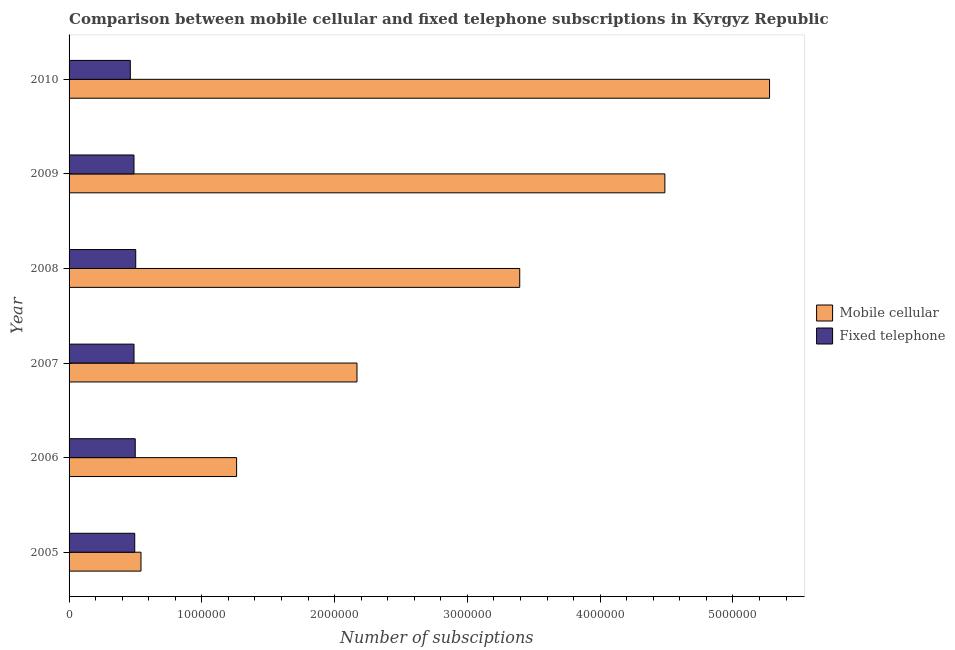How many different coloured bars are there?
Ensure brevity in your answer.  2. Are the number of bars per tick equal to the number of legend labels?
Make the answer very short. Yes. How many bars are there on the 4th tick from the bottom?
Provide a succinct answer. 2. What is the label of the 2nd group of bars from the top?
Give a very brief answer. 2009. In how many cases, is the number of bars for a given year not equal to the number of legend labels?
Keep it short and to the point. 0. What is the number of mobile cellular subscriptions in 2009?
Give a very brief answer. 4.49e+06. Across all years, what is the maximum number of fixed telephone subscriptions?
Make the answer very short. 5.02e+05. Across all years, what is the minimum number of fixed telephone subscriptions?
Offer a very short reply. 4.61e+05. What is the total number of mobile cellular subscriptions in the graph?
Your response must be concise. 1.71e+07. What is the difference between the number of mobile cellular subscriptions in 2007 and that in 2010?
Your answer should be compact. -3.11e+06. What is the difference between the number of mobile cellular subscriptions in 2009 and the number of fixed telephone subscriptions in 2010?
Provide a succinct answer. 4.03e+06. What is the average number of mobile cellular subscriptions per year?
Your answer should be very brief. 2.85e+06. In the year 2005, what is the difference between the number of mobile cellular subscriptions and number of fixed telephone subscriptions?
Provide a succinct answer. 4.71e+04. What is the ratio of the number of mobile cellular subscriptions in 2006 to that in 2009?
Provide a short and direct response. 0.28. What is the difference between the highest and the second highest number of mobile cellular subscriptions?
Provide a succinct answer. 7.88e+05. What is the difference between the highest and the lowest number of mobile cellular subscriptions?
Provide a succinct answer. 4.73e+06. In how many years, is the number of fixed telephone subscriptions greater than the average number of fixed telephone subscriptions taken over all years?
Keep it short and to the point. 4. Is the sum of the number of mobile cellular subscriptions in 2005 and 2010 greater than the maximum number of fixed telephone subscriptions across all years?
Ensure brevity in your answer.  Yes. What does the 1st bar from the top in 2010 represents?
Make the answer very short. Fixed telephone. What does the 2nd bar from the bottom in 2005 represents?
Your answer should be compact. Fixed telephone. How many years are there in the graph?
Offer a terse response. 6. What is the difference between two consecutive major ticks on the X-axis?
Your response must be concise. 1.00e+06. Does the graph contain grids?
Ensure brevity in your answer.  No. How many legend labels are there?
Ensure brevity in your answer.  2. What is the title of the graph?
Your response must be concise. Comparison between mobile cellular and fixed telephone subscriptions in Kyrgyz Republic. Does "Netherlands" appear as one of the legend labels in the graph?
Your response must be concise. No. What is the label or title of the X-axis?
Make the answer very short. Number of subsciptions. What is the label or title of the Y-axis?
Your answer should be very brief. Year. What is the Number of subsciptions of Mobile cellular in 2005?
Offer a terse response. 5.42e+05. What is the Number of subsciptions of Fixed telephone in 2005?
Your answer should be very brief. 4.95e+05. What is the Number of subsciptions in Mobile cellular in 2006?
Your answer should be very brief. 1.26e+06. What is the Number of subsciptions in Fixed telephone in 2006?
Give a very brief answer. 4.98e+05. What is the Number of subsciptions of Mobile cellular in 2007?
Offer a very short reply. 2.17e+06. What is the Number of subsciptions of Fixed telephone in 2007?
Your answer should be very brief. 4.89e+05. What is the Number of subsciptions in Mobile cellular in 2008?
Your answer should be compact. 3.39e+06. What is the Number of subsciptions in Fixed telephone in 2008?
Make the answer very short. 5.02e+05. What is the Number of subsciptions in Mobile cellular in 2009?
Provide a short and direct response. 4.49e+06. What is the Number of subsciptions in Fixed telephone in 2009?
Your answer should be compact. 4.89e+05. What is the Number of subsciptions of Mobile cellular in 2010?
Your response must be concise. 5.28e+06. What is the Number of subsciptions of Fixed telephone in 2010?
Offer a terse response. 4.61e+05. Across all years, what is the maximum Number of subsciptions of Mobile cellular?
Provide a succinct answer. 5.28e+06. Across all years, what is the maximum Number of subsciptions of Fixed telephone?
Give a very brief answer. 5.02e+05. Across all years, what is the minimum Number of subsciptions in Mobile cellular?
Your answer should be very brief. 5.42e+05. Across all years, what is the minimum Number of subsciptions in Fixed telephone?
Offer a very short reply. 4.61e+05. What is the total Number of subsciptions in Mobile cellular in the graph?
Provide a succinct answer. 1.71e+07. What is the total Number of subsciptions of Fixed telephone in the graph?
Give a very brief answer. 2.93e+06. What is the difference between the Number of subsciptions in Mobile cellular in 2005 and that in 2006?
Your answer should be very brief. -7.20e+05. What is the difference between the Number of subsciptions of Fixed telephone in 2005 and that in 2006?
Ensure brevity in your answer.  -3825. What is the difference between the Number of subsciptions of Mobile cellular in 2005 and that in 2007?
Keep it short and to the point. -1.63e+06. What is the difference between the Number of subsciptions of Fixed telephone in 2005 and that in 2007?
Offer a very short reply. 5451. What is the difference between the Number of subsciptions in Mobile cellular in 2005 and that in 2008?
Make the answer very short. -2.85e+06. What is the difference between the Number of subsciptions of Fixed telephone in 2005 and that in 2008?
Keep it short and to the point. -7517. What is the difference between the Number of subsciptions of Mobile cellular in 2005 and that in 2009?
Ensure brevity in your answer.  -3.95e+06. What is the difference between the Number of subsciptions in Fixed telephone in 2005 and that in 2009?
Keep it short and to the point. 5650. What is the difference between the Number of subsciptions of Mobile cellular in 2005 and that in 2010?
Provide a short and direct response. -4.73e+06. What is the difference between the Number of subsciptions in Fixed telephone in 2005 and that in 2010?
Your answer should be very brief. 3.32e+04. What is the difference between the Number of subsciptions in Mobile cellular in 2006 and that in 2007?
Give a very brief answer. -9.07e+05. What is the difference between the Number of subsciptions in Fixed telephone in 2006 and that in 2007?
Provide a short and direct response. 9276. What is the difference between the Number of subsciptions of Mobile cellular in 2006 and that in 2008?
Give a very brief answer. -2.13e+06. What is the difference between the Number of subsciptions of Fixed telephone in 2006 and that in 2008?
Your answer should be compact. -3692. What is the difference between the Number of subsciptions of Mobile cellular in 2006 and that in 2009?
Keep it short and to the point. -3.23e+06. What is the difference between the Number of subsciptions in Fixed telephone in 2006 and that in 2009?
Keep it short and to the point. 9475. What is the difference between the Number of subsciptions in Mobile cellular in 2006 and that in 2010?
Provide a succinct answer. -4.01e+06. What is the difference between the Number of subsciptions in Fixed telephone in 2006 and that in 2010?
Ensure brevity in your answer.  3.71e+04. What is the difference between the Number of subsciptions of Mobile cellular in 2007 and that in 2008?
Give a very brief answer. -1.23e+06. What is the difference between the Number of subsciptions of Fixed telephone in 2007 and that in 2008?
Your answer should be very brief. -1.30e+04. What is the difference between the Number of subsciptions in Mobile cellular in 2007 and that in 2009?
Give a very brief answer. -2.32e+06. What is the difference between the Number of subsciptions of Fixed telephone in 2007 and that in 2009?
Provide a short and direct response. 199. What is the difference between the Number of subsciptions in Mobile cellular in 2007 and that in 2010?
Keep it short and to the point. -3.11e+06. What is the difference between the Number of subsciptions of Fixed telephone in 2007 and that in 2010?
Offer a very short reply. 2.78e+04. What is the difference between the Number of subsciptions in Mobile cellular in 2008 and that in 2009?
Your response must be concise. -1.09e+06. What is the difference between the Number of subsciptions of Fixed telephone in 2008 and that in 2009?
Offer a terse response. 1.32e+04. What is the difference between the Number of subsciptions of Mobile cellular in 2008 and that in 2010?
Your response must be concise. -1.88e+06. What is the difference between the Number of subsciptions in Fixed telephone in 2008 and that in 2010?
Offer a terse response. 4.07e+04. What is the difference between the Number of subsciptions of Mobile cellular in 2009 and that in 2010?
Make the answer very short. -7.88e+05. What is the difference between the Number of subsciptions of Fixed telephone in 2009 and that in 2010?
Your answer should be very brief. 2.76e+04. What is the difference between the Number of subsciptions of Mobile cellular in 2005 and the Number of subsciptions of Fixed telephone in 2006?
Your answer should be compact. 4.33e+04. What is the difference between the Number of subsciptions of Mobile cellular in 2005 and the Number of subsciptions of Fixed telephone in 2007?
Give a very brief answer. 5.26e+04. What is the difference between the Number of subsciptions of Mobile cellular in 2005 and the Number of subsciptions of Fixed telephone in 2008?
Offer a very short reply. 3.96e+04. What is the difference between the Number of subsciptions of Mobile cellular in 2005 and the Number of subsciptions of Fixed telephone in 2009?
Your answer should be very brief. 5.28e+04. What is the difference between the Number of subsciptions of Mobile cellular in 2005 and the Number of subsciptions of Fixed telephone in 2010?
Provide a succinct answer. 8.04e+04. What is the difference between the Number of subsciptions in Mobile cellular in 2006 and the Number of subsciptions in Fixed telephone in 2007?
Your response must be concise. 7.73e+05. What is the difference between the Number of subsciptions of Mobile cellular in 2006 and the Number of subsciptions of Fixed telephone in 2008?
Your response must be concise. 7.60e+05. What is the difference between the Number of subsciptions in Mobile cellular in 2006 and the Number of subsciptions in Fixed telephone in 2009?
Keep it short and to the point. 7.73e+05. What is the difference between the Number of subsciptions of Mobile cellular in 2006 and the Number of subsciptions of Fixed telephone in 2010?
Offer a terse response. 8.00e+05. What is the difference between the Number of subsciptions of Mobile cellular in 2007 and the Number of subsciptions of Fixed telephone in 2008?
Keep it short and to the point. 1.67e+06. What is the difference between the Number of subsciptions in Mobile cellular in 2007 and the Number of subsciptions in Fixed telephone in 2009?
Offer a terse response. 1.68e+06. What is the difference between the Number of subsciptions in Mobile cellular in 2007 and the Number of subsciptions in Fixed telephone in 2010?
Offer a very short reply. 1.71e+06. What is the difference between the Number of subsciptions of Mobile cellular in 2008 and the Number of subsciptions of Fixed telephone in 2009?
Make the answer very short. 2.91e+06. What is the difference between the Number of subsciptions of Mobile cellular in 2008 and the Number of subsciptions of Fixed telephone in 2010?
Ensure brevity in your answer.  2.93e+06. What is the difference between the Number of subsciptions in Mobile cellular in 2009 and the Number of subsciptions in Fixed telephone in 2010?
Ensure brevity in your answer.  4.03e+06. What is the average Number of subsciptions of Mobile cellular per year?
Provide a succinct answer. 2.85e+06. What is the average Number of subsciptions in Fixed telephone per year?
Ensure brevity in your answer.  4.89e+05. In the year 2005, what is the difference between the Number of subsciptions in Mobile cellular and Number of subsciptions in Fixed telephone?
Your answer should be compact. 4.71e+04. In the year 2006, what is the difference between the Number of subsciptions in Mobile cellular and Number of subsciptions in Fixed telephone?
Provide a short and direct response. 7.63e+05. In the year 2007, what is the difference between the Number of subsciptions in Mobile cellular and Number of subsciptions in Fixed telephone?
Your answer should be compact. 1.68e+06. In the year 2008, what is the difference between the Number of subsciptions of Mobile cellular and Number of subsciptions of Fixed telephone?
Offer a very short reply. 2.89e+06. In the year 2009, what is the difference between the Number of subsciptions in Mobile cellular and Number of subsciptions in Fixed telephone?
Your response must be concise. 4.00e+06. In the year 2010, what is the difference between the Number of subsciptions of Mobile cellular and Number of subsciptions of Fixed telephone?
Your answer should be very brief. 4.81e+06. What is the ratio of the Number of subsciptions in Mobile cellular in 2005 to that in 2006?
Your answer should be compact. 0.43. What is the ratio of the Number of subsciptions of Fixed telephone in 2005 to that in 2006?
Provide a short and direct response. 0.99. What is the ratio of the Number of subsciptions of Mobile cellular in 2005 to that in 2007?
Your answer should be very brief. 0.25. What is the ratio of the Number of subsciptions of Fixed telephone in 2005 to that in 2007?
Your response must be concise. 1.01. What is the ratio of the Number of subsciptions in Mobile cellular in 2005 to that in 2008?
Provide a short and direct response. 0.16. What is the ratio of the Number of subsciptions of Fixed telephone in 2005 to that in 2008?
Provide a succinct answer. 0.98. What is the ratio of the Number of subsciptions of Mobile cellular in 2005 to that in 2009?
Provide a short and direct response. 0.12. What is the ratio of the Number of subsciptions of Fixed telephone in 2005 to that in 2009?
Ensure brevity in your answer.  1.01. What is the ratio of the Number of subsciptions of Mobile cellular in 2005 to that in 2010?
Your answer should be compact. 0.1. What is the ratio of the Number of subsciptions in Fixed telephone in 2005 to that in 2010?
Your response must be concise. 1.07. What is the ratio of the Number of subsciptions of Mobile cellular in 2006 to that in 2007?
Make the answer very short. 0.58. What is the ratio of the Number of subsciptions in Mobile cellular in 2006 to that in 2008?
Offer a terse response. 0.37. What is the ratio of the Number of subsciptions of Fixed telephone in 2006 to that in 2008?
Provide a short and direct response. 0.99. What is the ratio of the Number of subsciptions in Mobile cellular in 2006 to that in 2009?
Your answer should be compact. 0.28. What is the ratio of the Number of subsciptions of Fixed telephone in 2006 to that in 2009?
Your response must be concise. 1.02. What is the ratio of the Number of subsciptions of Mobile cellular in 2006 to that in 2010?
Give a very brief answer. 0.24. What is the ratio of the Number of subsciptions of Fixed telephone in 2006 to that in 2010?
Ensure brevity in your answer.  1.08. What is the ratio of the Number of subsciptions in Mobile cellular in 2007 to that in 2008?
Your answer should be very brief. 0.64. What is the ratio of the Number of subsciptions in Fixed telephone in 2007 to that in 2008?
Ensure brevity in your answer.  0.97. What is the ratio of the Number of subsciptions of Mobile cellular in 2007 to that in 2009?
Give a very brief answer. 0.48. What is the ratio of the Number of subsciptions of Mobile cellular in 2007 to that in 2010?
Provide a short and direct response. 0.41. What is the ratio of the Number of subsciptions of Fixed telephone in 2007 to that in 2010?
Provide a short and direct response. 1.06. What is the ratio of the Number of subsciptions of Mobile cellular in 2008 to that in 2009?
Ensure brevity in your answer.  0.76. What is the ratio of the Number of subsciptions of Fixed telephone in 2008 to that in 2009?
Offer a terse response. 1.03. What is the ratio of the Number of subsciptions in Mobile cellular in 2008 to that in 2010?
Keep it short and to the point. 0.64. What is the ratio of the Number of subsciptions in Fixed telephone in 2008 to that in 2010?
Your answer should be very brief. 1.09. What is the ratio of the Number of subsciptions in Mobile cellular in 2009 to that in 2010?
Ensure brevity in your answer.  0.85. What is the ratio of the Number of subsciptions of Fixed telephone in 2009 to that in 2010?
Your answer should be compact. 1.06. What is the difference between the highest and the second highest Number of subsciptions in Mobile cellular?
Make the answer very short. 7.88e+05. What is the difference between the highest and the second highest Number of subsciptions in Fixed telephone?
Give a very brief answer. 3692. What is the difference between the highest and the lowest Number of subsciptions in Mobile cellular?
Ensure brevity in your answer.  4.73e+06. What is the difference between the highest and the lowest Number of subsciptions of Fixed telephone?
Provide a succinct answer. 4.07e+04. 